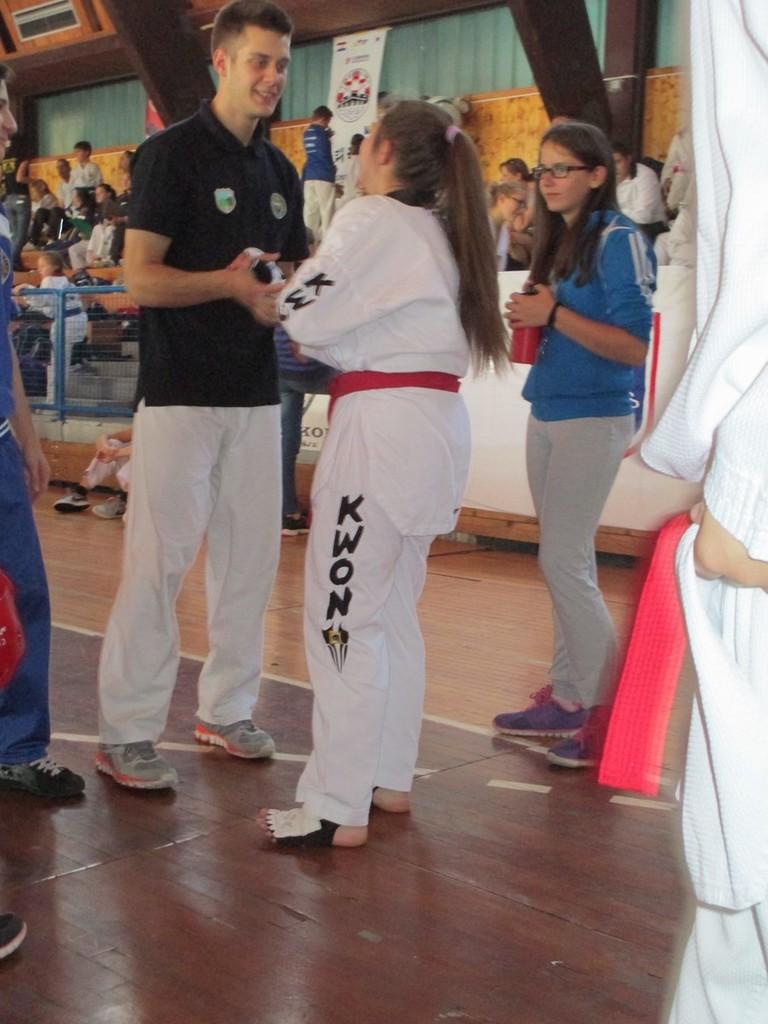How is her pant leg titled?
Offer a terse response. Kwon. 